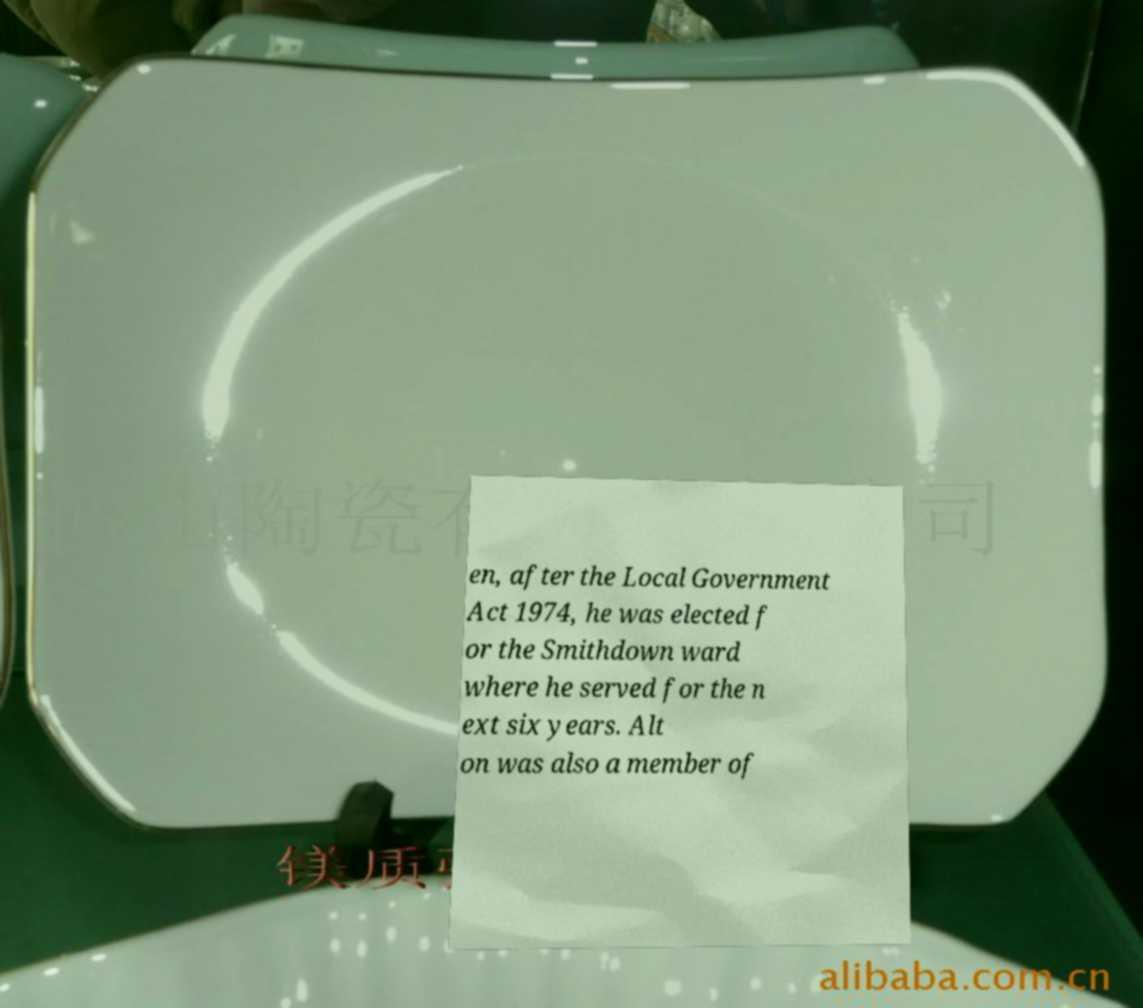Please identify and transcribe the text found in this image. en, after the Local Government Act 1974, he was elected f or the Smithdown ward where he served for the n ext six years. Alt on was also a member of 